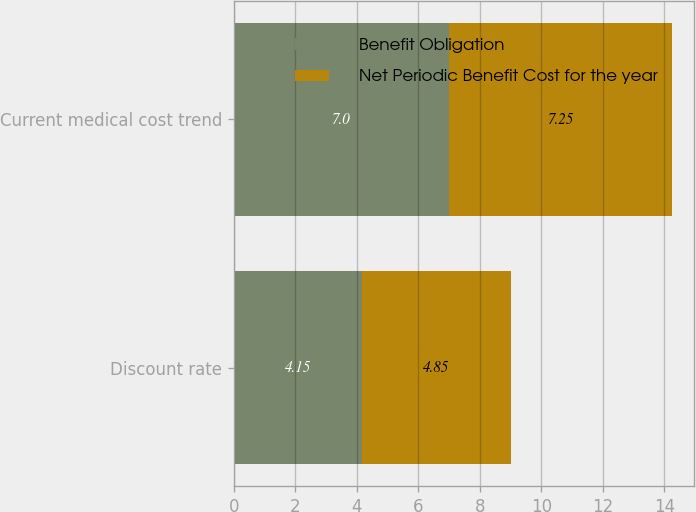Convert chart. <chart><loc_0><loc_0><loc_500><loc_500><stacked_bar_chart><ecel><fcel>Discount rate<fcel>Current medical cost trend<nl><fcel>Benefit Obligation<fcel>4.15<fcel>7<nl><fcel>Net Periodic Benefit Cost for the year<fcel>4.85<fcel>7.25<nl></chart> 